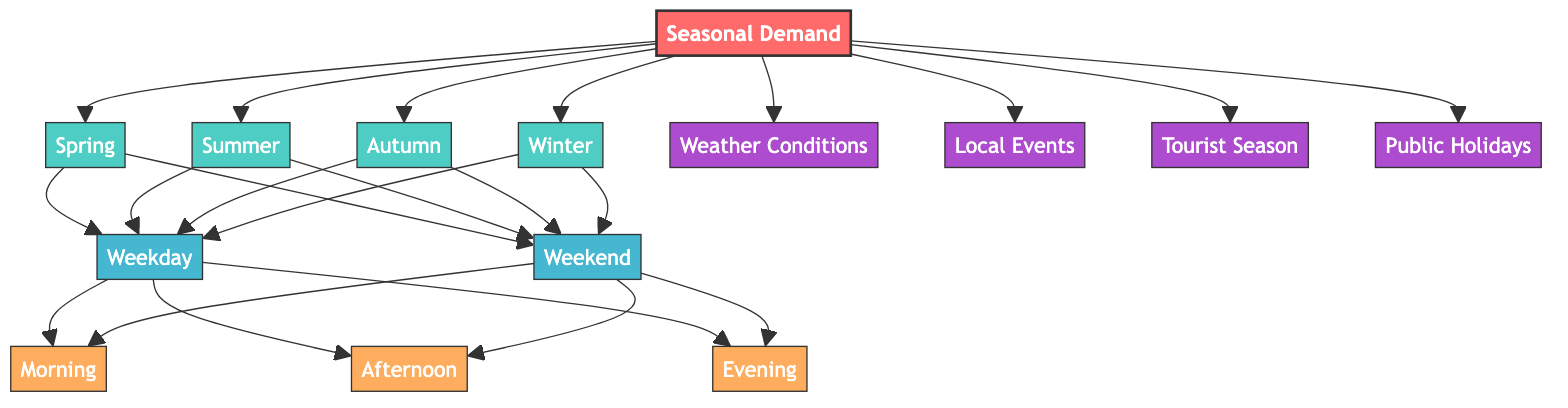What is the main node in the diagram? The main node in the diagram is "Seasonal Demand", as it is the central focus from which all other nodes branch out.
Answer: Seasonal Demand How many seasons are represented in the diagram? The diagram displays four seasons: Spring, Summer, Autumn, and Winter, as indicated by the respective nodes connected to the main node.
Answer: 4 Which days relate to Spring according to the diagram? The diagram shows that both "Weekday" and "Weekend" are connected to the "Spring" node, indicating these days affect the demand for rentals in the Spring.
Answer: Weekday, Weekend What is the influence connected to seasonal demand that relates to special events? The "Local Events" node is connected to the "Seasonal Demand" node, indicating that such events influence the demand for rentals.
Answer: Local Events Which time slots are associated with Weekday? The "Morning," "Afternoon," and "Evening" nodes are all connected to the "Weekday" node, indicating that these time slots are relevant for bike and e-scooter rentals on weekdays.
Answer: Morning, Afternoon, Evening How do weather conditions affect seasonal demand? "Weather Conditions" is an influence node connected directly to "Seasonal Demand," showing that weather impacts the demand for rentals throughout the seasons.
Answer: Weather Conditions What nodes influence the demand for rentals in any season? The influence nodes "Weather Conditions," "Local Events," "Tourist Season," and "Public Holidays" are all connected to "Seasonal Demand," indicating they affect rental demand in any season.
Answer: Weather Conditions, Local Events, Tourist Season, Public Holidays Can you name a specific time associated with Weekend? Both "Morning," "Afternoon," and "Evening" are time nodes connected to the "Weekend" node, showing that these specific times are relevant for rentals on weekends.
Answer: Morning, Afternoon, Evening What type of node is "Autumn"? "Autumn" is categorized as a "season" node, identified by its connection to the main node "Seasonal Demand" within the diagram.
Answer: season 